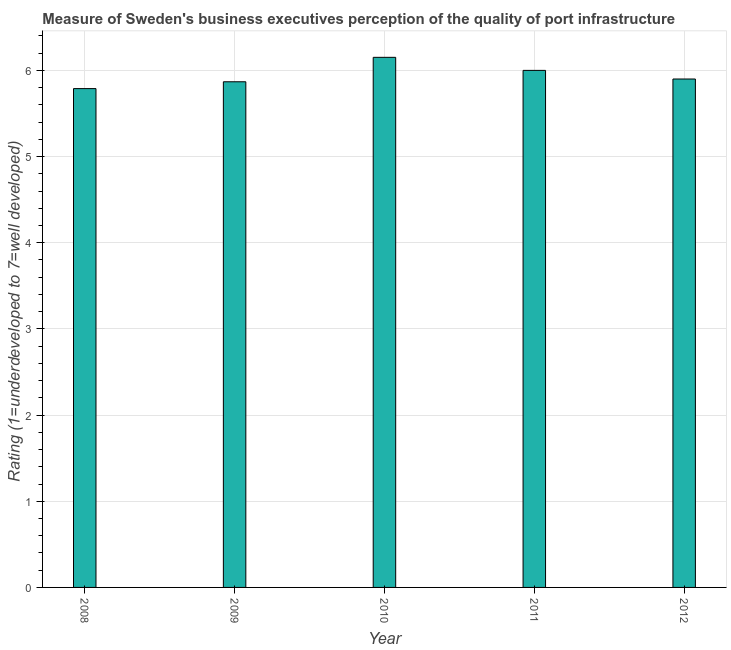Does the graph contain grids?
Your answer should be very brief. Yes. What is the title of the graph?
Keep it short and to the point. Measure of Sweden's business executives perception of the quality of port infrastructure. What is the label or title of the Y-axis?
Offer a very short reply. Rating (1=underdeveloped to 7=well developed) . What is the rating measuring quality of port infrastructure in 2008?
Provide a succinct answer. 5.79. Across all years, what is the maximum rating measuring quality of port infrastructure?
Provide a short and direct response. 6.15. Across all years, what is the minimum rating measuring quality of port infrastructure?
Give a very brief answer. 5.79. In which year was the rating measuring quality of port infrastructure maximum?
Your answer should be very brief. 2010. What is the sum of the rating measuring quality of port infrastructure?
Your answer should be very brief. 29.71. What is the difference between the rating measuring quality of port infrastructure in 2008 and 2009?
Provide a short and direct response. -0.08. What is the average rating measuring quality of port infrastructure per year?
Make the answer very short. 5.94. What is the median rating measuring quality of port infrastructure?
Give a very brief answer. 5.9. In how many years, is the rating measuring quality of port infrastructure greater than 3 ?
Provide a short and direct response. 5. Do a majority of the years between 2008 and 2009 (inclusive) have rating measuring quality of port infrastructure greater than 4.6 ?
Your answer should be very brief. Yes. What is the ratio of the rating measuring quality of port infrastructure in 2009 to that in 2010?
Ensure brevity in your answer.  0.95. What is the difference between the highest and the second highest rating measuring quality of port infrastructure?
Offer a terse response. 0.15. Is the sum of the rating measuring quality of port infrastructure in 2009 and 2012 greater than the maximum rating measuring quality of port infrastructure across all years?
Your answer should be compact. Yes. What is the difference between the highest and the lowest rating measuring quality of port infrastructure?
Your response must be concise. 0.36. In how many years, is the rating measuring quality of port infrastructure greater than the average rating measuring quality of port infrastructure taken over all years?
Your response must be concise. 2. How many bars are there?
Ensure brevity in your answer.  5. Are all the bars in the graph horizontal?
Ensure brevity in your answer.  No. What is the difference between two consecutive major ticks on the Y-axis?
Your answer should be very brief. 1. What is the Rating (1=underdeveloped to 7=well developed)  of 2008?
Keep it short and to the point. 5.79. What is the Rating (1=underdeveloped to 7=well developed)  in 2009?
Keep it short and to the point. 5.87. What is the Rating (1=underdeveloped to 7=well developed)  in 2010?
Ensure brevity in your answer.  6.15. What is the difference between the Rating (1=underdeveloped to 7=well developed)  in 2008 and 2009?
Offer a terse response. -0.08. What is the difference between the Rating (1=underdeveloped to 7=well developed)  in 2008 and 2010?
Give a very brief answer. -0.36. What is the difference between the Rating (1=underdeveloped to 7=well developed)  in 2008 and 2011?
Your answer should be very brief. -0.21. What is the difference between the Rating (1=underdeveloped to 7=well developed)  in 2008 and 2012?
Make the answer very short. -0.11. What is the difference between the Rating (1=underdeveloped to 7=well developed)  in 2009 and 2010?
Keep it short and to the point. -0.28. What is the difference between the Rating (1=underdeveloped to 7=well developed)  in 2009 and 2011?
Your answer should be very brief. -0.13. What is the difference between the Rating (1=underdeveloped to 7=well developed)  in 2009 and 2012?
Offer a very short reply. -0.03. What is the difference between the Rating (1=underdeveloped to 7=well developed)  in 2010 and 2011?
Give a very brief answer. 0.15. What is the difference between the Rating (1=underdeveloped to 7=well developed)  in 2010 and 2012?
Offer a terse response. 0.25. What is the ratio of the Rating (1=underdeveloped to 7=well developed)  in 2008 to that in 2010?
Provide a short and direct response. 0.94. What is the ratio of the Rating (1=underdeveloped to 7=well developed)  in 2008 to that in 2011?
Make the answer very short. 0.96. What is the ratio of the Rating (1=underdeveloped to 7=well developed)  in 2008 to that in 2012?
Give a very brief answer. 0.98. What is the ratio of the Rating (1=underdeveloped to 7=well developed)  in 2009 to that in 2010?
Your response must be concise. 0.95. What is the ratio of the Rating (1=underdeveloped to 7=well developed)  in 2009 to that in 2011?
Make the answer very short. 0.98. What is the ratio of the Rating (1=underdeveloped to 7=well developed)  in 2010 to that in 2012?
Offer a very short reply. 1.04. What is the ratio of the Rating (1=underdeveloped to 7=well developed)  in 2011 to that in 2012?
Your response must be concise. 1.02. 